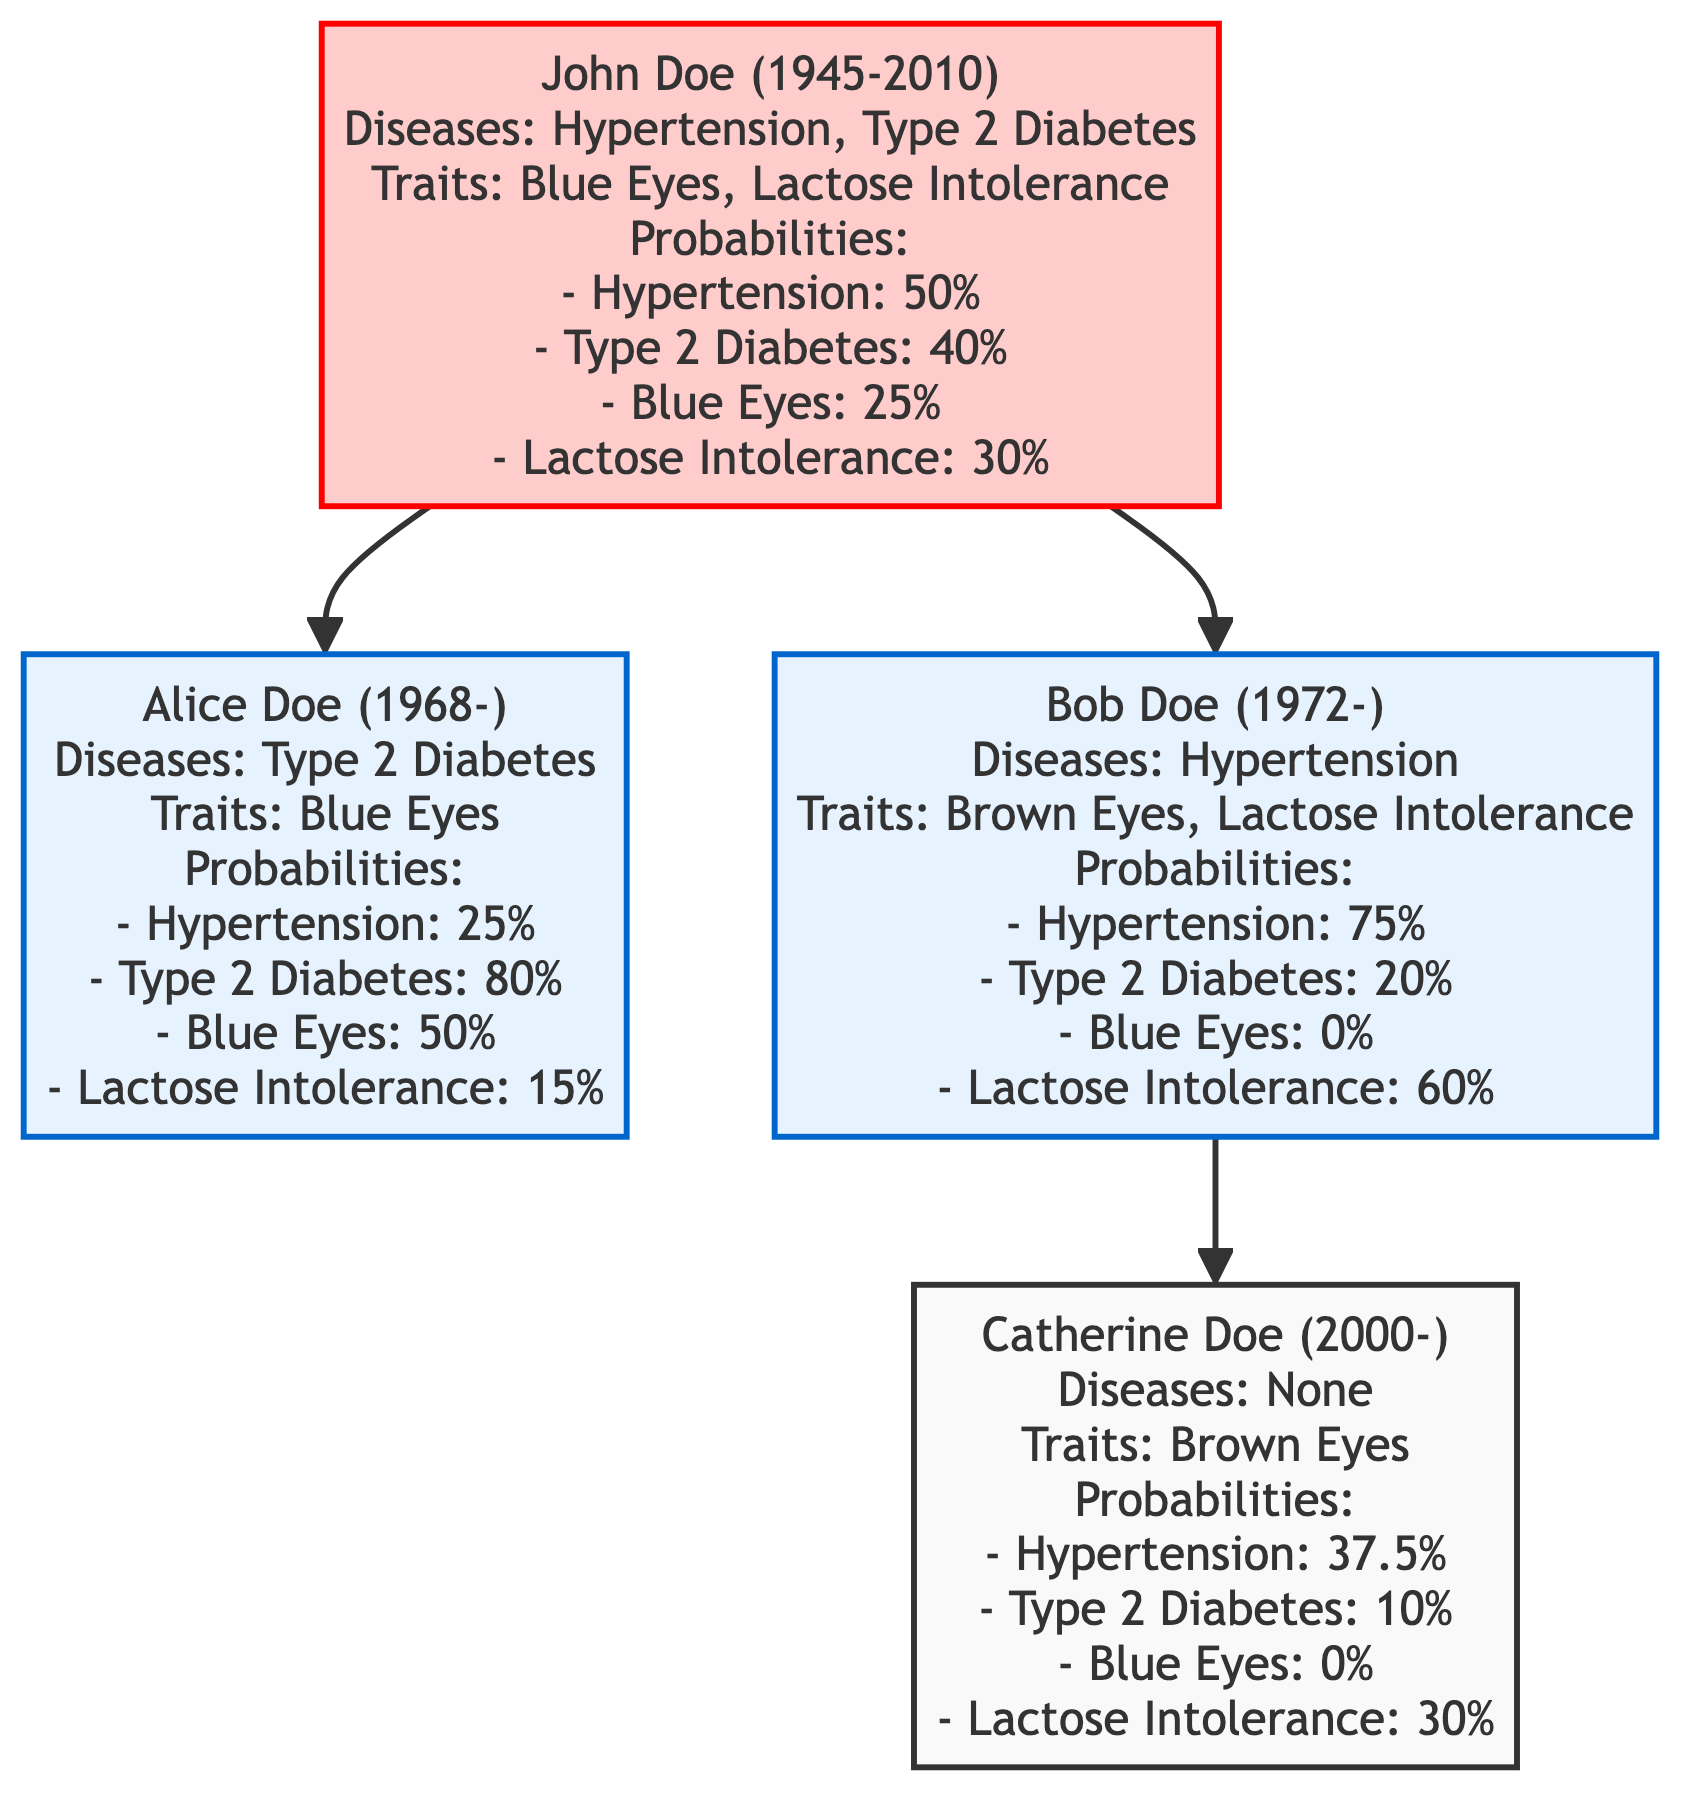What is John Doe's year of birth? The diagram shows that John Doe was born in 1945, which is clearly indicated next to his name.
Answer: 1945 How many diseases does Alice Doe have? According to the diagram, Alice Doe has one listed disease: Type 2 Diabetes.
Answer: 1 What is the probability of Hypertension for Bob Doe? The diagram lists Bob Doe's probability of Hypertension as 75%. This information is found in the medical history section associated with his node.
Answer: 75% Which eye color trait does Catherine Doe have? The diagram notes that Catherine Doe has Brown Eyes as her genetic trait, which is indicated right next to her name in the traits section.
Answer: Brown Eyes Who are the children of Bob Doe? The diagram shows that Bob Doe has one child listed, Catherine Doe, which is shown as a direct descendant from Bob Doe's node.
Answer: Catherine Doe What is the lowest probability of Type 2 Diabetes among the family members? Comparing the probabilities displayed in the diagram, Catherine Doe has the lowest probability of Type 2 Diabetes at 10%. This is determined by reviewing the probabilities for each individual.
Answer: 10% What relationship does Alice Doe have with John Doe? The diagram indicates that Alice Doe is a child of John Doe, as shown by the direct connection (arrow) from John Doe's node to Alice Doe's node.
Answer: Child How many total edges are there in the family tree? The diagram shows three connections (edges): John Doe to Alice Doe, John Doe to Bob Doe, and Bob Doe to Catherine Doe, totaling three edges.
Answer: 3 